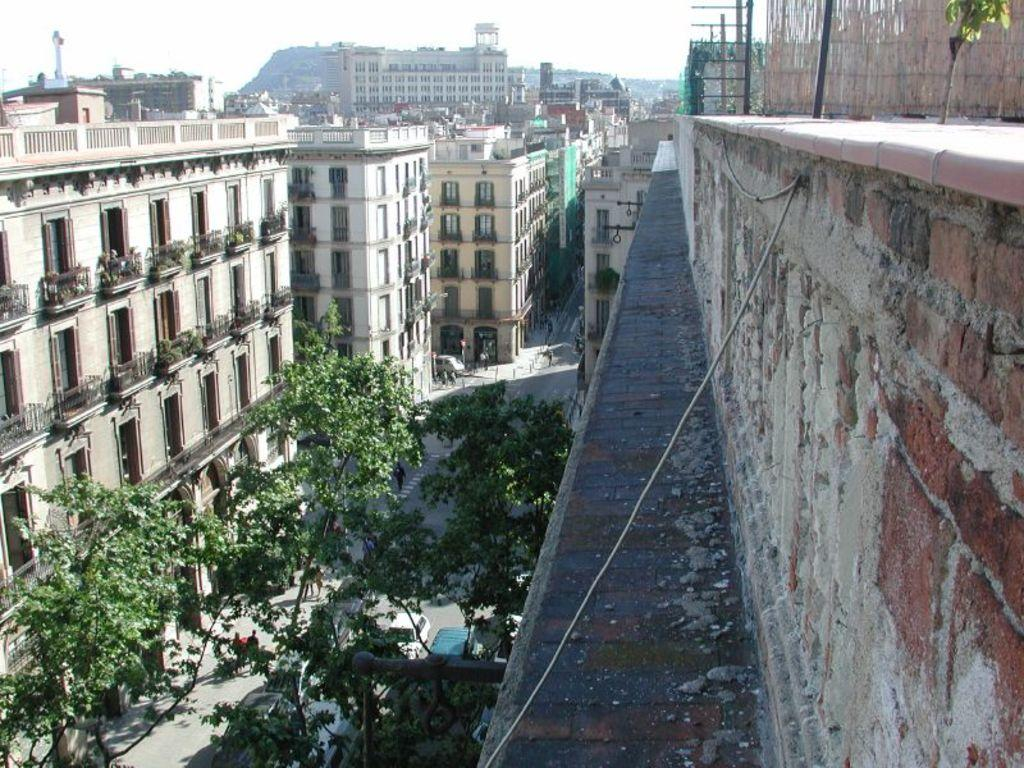What type of structures can be seen in the image? There are buildings in the image. What other natural elements are present in the image? There are trees in the image. What mode of transportation can be seen on the road in the image? There are vehicles on the road in the image. What geographical feature is visible in the image? There is a hill in the image. What part of the environment is visible in the image? The sky is visible in the image. What type of disease is affecting the behavior of the trees in the image? There is no indication of any disease affecting the trees in the image; they appear to be healthy. What degree of education is required to understand the image? The image does not require any specific degree of education to understand; it is a simple scene of buildings, trees, vehicles, a hill, and the sky. 